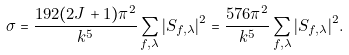<formula> <loc_0><loc_0><loc_500><loc_500>\sigma = \frac { 1 9 2 ( 2 J + 1 ) \pi ^ { 2 } } { k ^ { 5 } } \sum _ { f , \lambda } | S _ { f , \lambda } | ^ { 2 } = \frac { 5 7 6 \pi ^ { 2 } } { k ^ { 5 } } \sum _ { f , \lambda } | S _ { f , \lambda } | ^ { 2 } .</formula> 